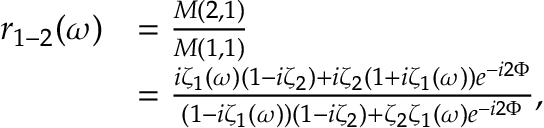<formula> <loc_0><loc_0><loc_500><loc_500>\begin{array} { r l } { r _ { 1 - 2 } ( \omega ) } & { = \frac { M ( 2 , 1 ) } { M ( 1 , 1 ) } } \\ & { = \frac { i \zeta _ { 1 } ( \omega ) ( 1 - i \zeta _ { 2 } ) + i \zeta _ { 2 } ( 1 + i \zeta _ { 1 } ( \omega ) ) e ^ { - i 2 \Phi } } { ( 1 - i \zeta _ { 1 } ( \omega ) ) ( 1 - i \zeta _ { 2 } ) + \zeta _ { 2 } \zeta _ { 1 } ( \omega ) e ^ { - i 2 \Phi } } , } \end{array}</formula> 